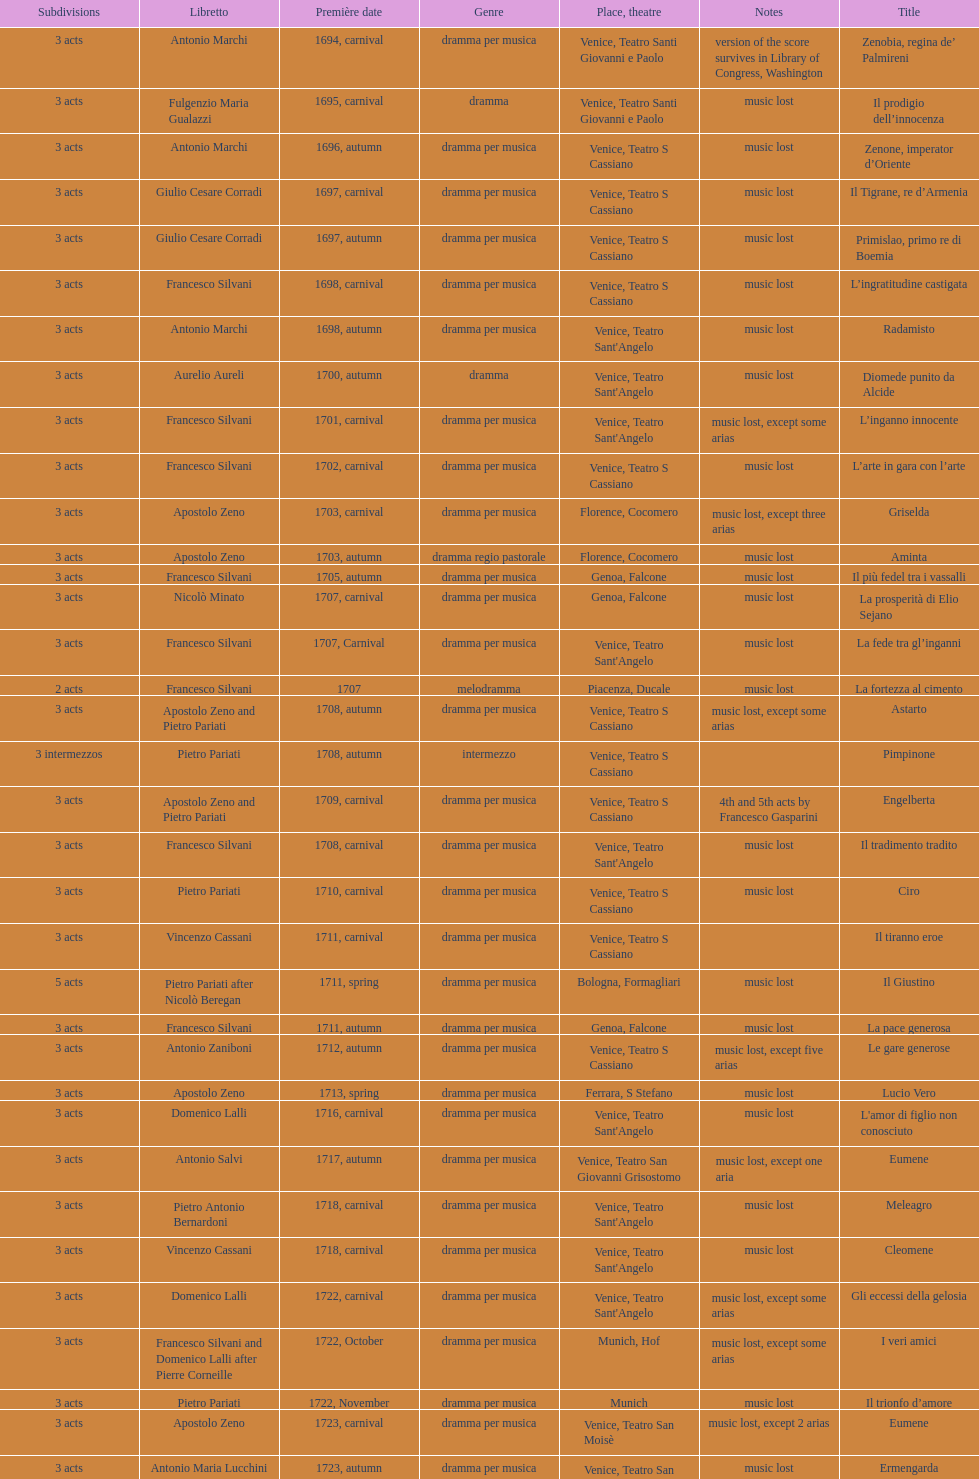How many were unleashed after zenone, imperator d'oriente? 52. 